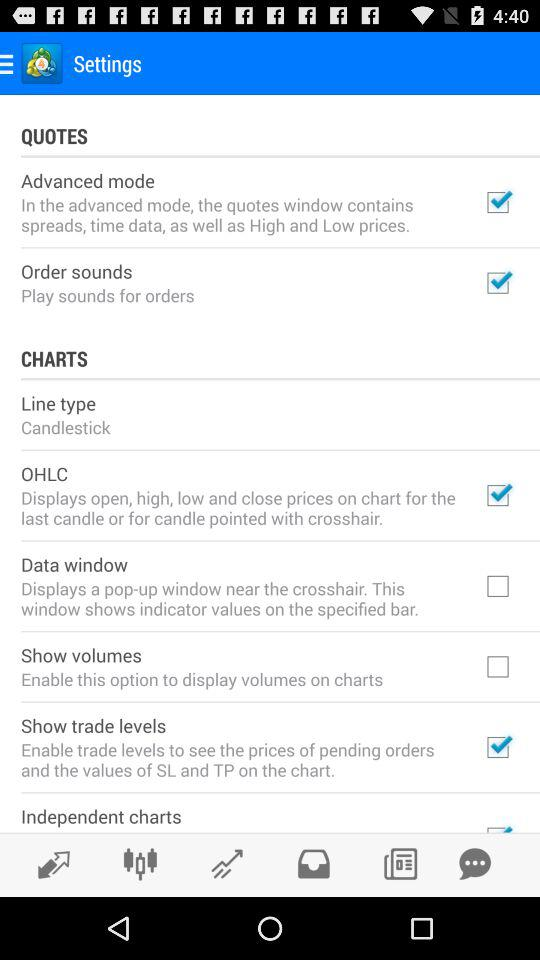Which options are checked in the charts? The options checked in the charts are "OHLC" and "Show trade levels". 